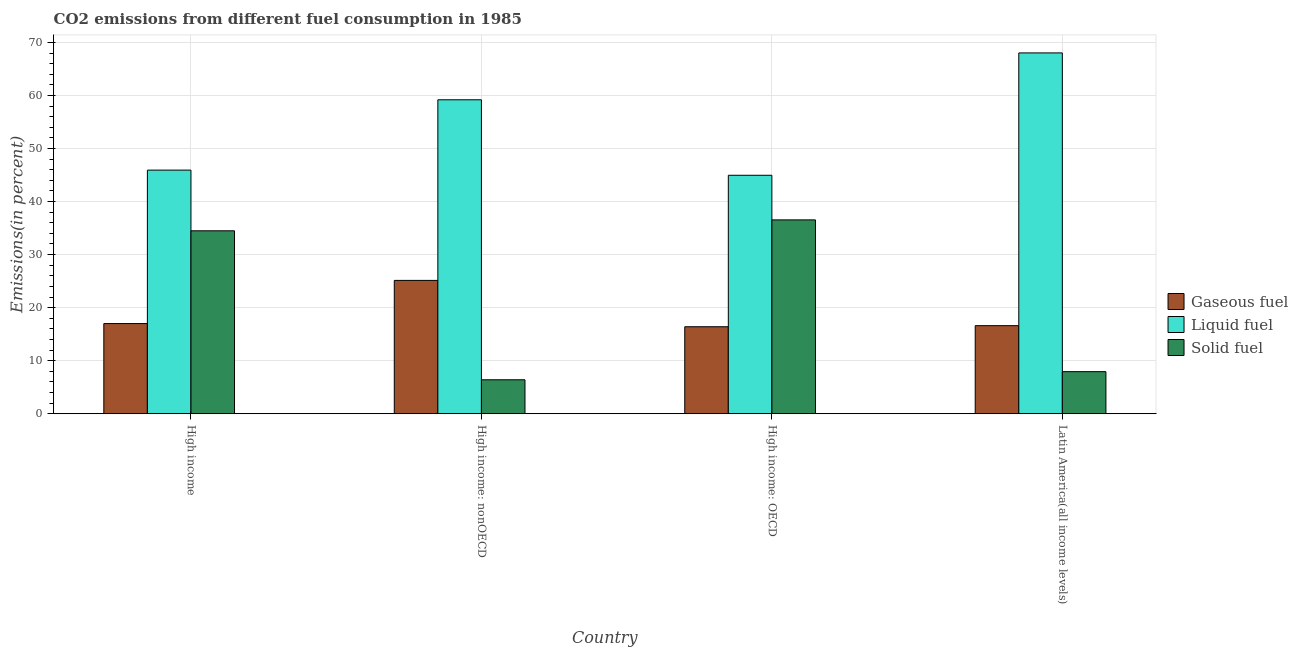How many different coloured bars are there?
Ensure brevity in your answer.  3. How many groups of bars are there?
Provide a succinct answer. 4. Are the number of bars per tick equal to the number of legend labels?
Provide a succinct answer. Yes. What is the percentage of solid fuel emission in High income?
Your response must be concise. 34.49. Across all countries, what is the maximum percentage of solid fuel emission?
Provide a short and direct response. 36.54. Across all countries, what is the minimum percentage of liquid fuel emission?
Provide a succinct answer. 44.96. In which country was the percentage of liquid fuel emission maximum?
Provide a succinct answer. Latin America(all income levels). In which country was the percentage of liquid fuel emission minimum?
Your response must be concise. High income: OECD. What is the total percentage of solid fuel emission in the graph?
Your answer should be compact. 85.36. What is the difference between the percentage of solid fuel emission in High income: OECD and that in Latin America(all income levels)?
Make the answer very short. 28.61. What is the difference between the percentage of gaseous fuel emission in High income: OECD and the percentage of solid fuel emission in High income?
Give a very brief answer. -18.08. What is the average percentage of gaseous fuel emission per country?
Give a very brief answer. 18.78. What is the difference between the percentage of gaseous fuel emission and percentage of liquid fuel emission in High income?
Your response must be concise. -28.93. In how many countries, is the percentage of liquid fuel emission greater than 38 %?
Offer a terse response. 4. What is the ratio of the percentage of solid fuel emission in High income: nonOECD to that in Latin America(all income levels)?
Offer a terse response. 0.81. Is the percentage of gaseous fuel emission in High income: OECD less than that in High income: nonOECD?
Your answer should be compact. Yes. What is the difference between the highest and the second highest percentage of gaseous fuel emission?
Ensure brevity in your answer.  8.14. What is the difference between the highest and the lowest percentage of liquid fuel emission?
Offer a terse response. 23.07. Is the sum of the percentage of gaseous fuel emission in High income: nonOECD and Latin America(all income levels) greater than the maximum percentage of solid fuel emission across all countries?
Your answer should be very brief. Yes. What does the 3rd bar from the left in High income represents?
Make the answer very short. Solid fuel. What does the 3rd bar from the right in High income: OECD represents?
Provide a succinct answer. Gaseous fuel. Where does the legend appear in the graph?
Your response must be concise. Center right. How many legend labels are there?
Ensure brevity in your answer.  3. What is the title of the graph?
Ensure brevity in your answer.  CO2 emissions from different fuel consumption in 1985. What is the label or title of the Y-axis?
Provide a short and direct response. Emissions(in percent). What is the Emissions(in percent) in Gaseous fuel in High income?
Provide a succinct answer. 17. What is the Emissions(in percent) of Liquid fuel in High income?
Your answer should be compact. 45.93. What is the Emissions(in percent) in Solid fuel in High income?
Keep it short and to the point. 34.49. What is the Emissions(in percent) of Gaseous fuel in High income: nonOECD?
Give a very brief answer. 25.14. What is the Emissions(in percent) of Liquid fuel in High income: nonOECD?
Give a very brief answer. 59.19. What is the Emissions(in percent) of Solid fuel in High income: nonOECD?
Provide a short and direct response. 6.4. What is the Emissions(in percent) in Gaseous fuel in High income: OECD?
Your answer should be compact. 16.4. What is the Emissions(in percent) in Liquid fuel in High income: OECD?
Give a very brief answer. 44.96. What is the Emissions(in percent) of Solid fuel in High income: OECD?
Your response must be concise. 36.54. What is the Emissions(in percent) of Gaseous fuel in Latin America(all income levels)?
Make the answer very short. 16.6. What is the Emissions(in percent) of Liquid fuel in Latin America(all income levels)?
Provide a succinct answer. 68.02. What is the Emissions(in percent) of Solid fuel in Latin America(all income levels)?
Your answer should be very brief. 7.93. Across all countries, what is the maximum Emissions(in percent) in Gaseous fuel?
Your answer should be compact. 25.14. Across all countries, what is the maximum Emissions(in percent) of Liquid fuel?
Your response must be concise. 68.02. Across all countries, what is the maximum Emissions(in percent) in Solid fuel?
Your response must be concise. 36.54. Across all countries, what is the minimum Emissions(in percent) in Gaseous fuel?
Your answer should be very brief. 16.4. Across all countries, what is the minimum Emissions(in percent) of Liquid fuel?
Offer a very short reply. 44.96. Across all countries, what is the minimum Emissions(in percent) of Solid fuel?
Give a very brief answer. 6.4. What is the total Emissions(in percent) of Gaseous fuel in the graph?
Keep it short and to the point. 75.14. What is the total Emissions(in percent) of Liquid fuel in the graph?
Provide a short and direct response. 218.09. What is the total Emissions(in percent) in Solid fuel in the graph?
Make the answer very short. 85.36. What is the difference between the Emissions(in percent) in Gaseous fuel in High income and that in High income: nonOECD?
Your answer should be very brief. -8.14. What is the difference between the Emissions(in percent) of Liquid fuel in High income and that in High income: nonOECD?
Make the answer very short. -13.26. What is the difference between the Emissions(in percent) of Solid fuel in High income and that in High income: nonOECD?
Provide a succinct answer. 28.08. What is the difference between the Emissions(in percent) of Gaseous fuel in High income and that in High income: OECD?
Make the answer very short. 0.6. What is the difference between the Emissions(in percent) of Liquid fuel in High income and that in High income: OECD?
Offer a terse response. 0.97. What is the difference between the Emissions(in percent) of Solid fuel in High income and that in High income: OECD?
Offer a very short reply. -2.06. What is the difference between the Emissions(in percent) in Gaseous fuel in High income and that in Latin America(all income levels)?
Your response must be concise. 0.4. What is the difference between the Emissions(in percent) of Liquid fuel in High income and that in Latin America(all income levels)?
Your response must be concise. -22.09. What is the difference between the Emissions(in percent) in Solid fuel in High income and that in Latin America(all income levels)?
Your answer should be compact. 26.55. What is the difference between the Emissions(in percent) in Gaseous fuel in High income: nonOECD and that in High income: OECD?
Ensure brevity in your answer.  8.74. What is the difference between the Emissions(in percent) of Liquid fuel in High income: nonOECD and that in High income: OECD?
Ensure brevity in your answer.  14.23. What is the difference between the Emissions(in percent) of Solid fuel in High income: nonOECD and that in High income: OECD?
Your response must be concise. -30.14. What is the difference between the Emissions(in percent) of Gaseous fuel in High income: nonOECD and that in Latin America(all income levels)?
Provide a succinct answer. 8.54. What is the difference between the Emissions(in percent) in Liquid fuel in High income: nonOECD and that in Latin America(all income levels)?
Keep it short and to the point. -8.84. What is the difference between the Emissions(in percent) in Solid fuel in High income: nonOECD and that in Latin America(all income levels)?
Ensure brevity in your answer.  -1.53. What is the difference between the Emissions(in percent) in Gaseous fuel in High income: OECD and that in Latin America(all income levels)?
Keep it short and to the point. -0.2. What is the difference between the Emissions(in percent) in Liquid fuel in High income: OECD and that in Latin America(all income levels)?
Keep it short and to the point. -23.07. What is the difference between the Emissions(in percent) in Solid fuel in High income: OECD and that in Latin America(all income levels)?
Your answer should be very brief. 28.61. What is the difference between the Emissions(in percent) of Gaseous fuel in High income and the Emissions(in percent) of Liquid fuel in High income: nonOECD?
Provide a succinct answer. -42.19. What is the difference between the Emissions(in percent) in Gaseous fuel in High income and the Emissions(in percent) in Solid fuel in High income: nonOECD?
Your response must be concise. 10.59. What is the difference between the Emissions(in percent) in Liquid fuel in High income and the Emissions(in percent) in Solid fuel in High income: nonOECD?
Offer a very short reply. 39.52. What is the difference between the Emissions(in percent) in Gaseous fuel in High income and the Emissions(in percent) in Liquid fuel in High income: OECD?
Provide a succinct answer. -27.96. What is the difference between the Emissions(in percent) of Gaseous fuel in High income and the Emissions(in percent) of Solid fuel in High income: OECD?
Your answer should be compact. -19.55. What is the difference between the Emissions(in percent) of Liquid fuel in High income and the Emissions(in percent) of Solid fuel in High income: OECD?
Offer a terse response. 9.38. What is the difference between the Emissions(in percent) in Gaseous fuel in High income and the Emissions(in percent) in Liquid fuel in Latin America(all income levels)?
Give a very brief answer. -51.02. What is the difference between the Emissions(in percent) in Gaseous fuel in High income and the Emissions(in percent) in Solid fuel in Latin America(all income levels)?
Offer a very short reply. 9.07. What is the difference between the Emissions(in percent) in Liquid fuel in High income and the Emissions(in percent) in Solid fuel in Latin America(all income levels)?
Offer a very short reply. 38. What is the difference between the Emissions(in percent) of Gaseous fuel in High income: nonOECD and the Emissions(in percent) of Liquid fuel in High income: OECD?
Make the answer very short. -19.82. What is the difference between the Emissions(in percent) in Gaseous fuel in High income: nonOECD and the Emissions(in percent) in Solid fuel in High income: OECD?
Offer a very short reply. -11.41. What is the difference between the Emissions(in percent) of Liquid fuel in High income: nonOECD and the Emissions(in percent) of Solid fuel in High income: OECD?
Your answer should be compact. 22.64. What is the difference between the Emissions(in percent) in Gaseous fuel in High income: nonOECD and the Emissions(in percent) in Liquid fuel in Latin America(all income levels)?
Your answer should be very brief. -42.88. What is the difference between the Emissions(in percent) in Gaseous fuel in High income: nonOECD and the Emissions(in percent) in Solid fuel in Latin America(all income levels)?
Your answer should be very brief. 17.21. What is the difference between the Emissions(in percent) of Liquid fuel in High income: nonOECD and the Emissions(in percent) of Solid fuel in Latin America(all income levels)?
Provide a short and direct response. 51.25. What is the difference between the Emissions(in percent) of Gaseous fuel in High income: OECD and the Emissions(in percent) of Liquid fuel in Latin America(all income levels)?
Give a very brief answer. -51.62. What is the difference between the Emissions(in percent) of Gaseous fuel in High income: OECD and the Emissions(in percent) of Solid fuel in Latin America(all income levels)?
Provide a short and direct response. 8.47. What is the difference between the Emissions(in percent) of Liquid fuel in High income: OECD and the Emissions(in percent) of Solid fuel in Latin America(all income levels)?
Keep it short and to the point. 37.02. What is the average Emissions(in percent) of Gaseous fuel per country?
Provide a succinct answer. 18.78. What is the average Emissions(in percent) in Liquid fuel per country?
Provide a short and direct response. 54.52. What is the average Emissions(in percent) of Solid fuel per country?
Provide a succinct answer. 21.34. What is the difference between the Emissions(in percent) in Gaseous fuel and Emissions(in percent) in Liquid fuel in High income?
Make the answer very short. -28.93. What is the difference between the Emissions(in percent) in Gaseous fuel and Emissions(in percent) in Solid fuel in High income?
Your answer should be very brief. -17.49. What is the difference between the Emissions(in percent) in Liquid fuel and Emissions(in percent) in Solid fuel in High income?
Ensure brevity in your answer.  11.44. What is the difference between the Emissions(in percent) in Gaseous fuel and Emissions(in percent) in Liquid fuel in High income: nonOECD?
Your answer should be very brief. -34.05. What is the difference between the Emissions(in percent) of Gaseous fuel and Emissions(in percent) of Solid fuel in High income: nonOECD?
Your response must be concise. 18.73. What is the difference between the Emissions(in percent) of Liquid fuel and Emissions(in percent) of Solid fuel in High income: nonOECD?
Give a very brief answer. 52.78. What is the difference between the Emissions(in percent) of Gaseous fuel and Emissions(in percent) of Liquid fuel in High income: OECD?
Keep it short and to the point. -28.55. What is the difference between the Emissions(in percent) of Gaseous fuel and Emissions(in percent) of Solid fuel in High income: OECD?
Give a very brief answer. -20.14. What is the difference between the Emissions(in percent) of Liquid fuel and Emissions(in percent) of Solid fuel in High income: OECD?
Provide a succinct answer. 8.41. What is the difference between the Emissions(in percent) of Gaseous fuel and Emissions(in percent) of Liquid fuel in Latin America(all income levels)?
Your response must be concise. -51.42. What is the difference between the Emissions(in percent) in Gaseous fuel and Emissions(in percent) in Solid fuel in Latin America(all income levels)?
Make the answer very short. 8.67. What is the difference between the Emissions(in percent) of Liquid fuel and Emissions(in percent) of Solid fuel in Latin America(all income levels)?
Your answer should be compact. 60.09. What is the ratio of the Emissions(in percent) of Gaseous fuel in High income to that in High income: nonOECD?
Give a very brief answer. 0.68. What is the ratio of the Emissions(in percent) in Liquid fuel in High income to that in High income: nonOECD?
Your answer should be compact. 0.78. What is the ratio of the Emissions(in percent) of Solid fuel in High income to that in High income: nonOECD?
Your answer should be compact. 5.38. What is the ratio of the Emissions(in percent) of Gaseous fuel in High income to that in High income: OECD?
Offer a very short reply. 1.04. What is the ratio of the Emissions(in percent) of Liquid fuel in High income to that in High income: OECD?
Provide a short and direct response. 1.02. What is the ratio of the Emissions(in percent) of Solid fuel in High income to that in High income: OECD?
Your answer should be compact. 0.94. What is the ratio of the Emissions(in percent) of Gaseous fuel in High income to that in Latin America(all income levels)?
Your answer should be compact. 1.02. What is the ratio of the Emissions(in percent) of Liquid fuel in High income to that in Latin America(all income levels)?
Your answer should be compact. 0.68. What is the ratio of the Emissions(in percent) in Solid fuel in High income to that in Latin America(all income levels)?
Offer a very short reply. 4.35. What is the ratio of the Emissions(in percent) of Gaseous fuel in High income: nonOECD to that in High income: OECD?
Ensure brevity in your answer.  1.53. What is the ratio of the Emissions(in percent) of Liquid fuel in High income: nonOECD to that in High income: OECD?
Offer a terse response. 1.32. What is the ratio of the Emissions(in percent) of Solid fuel in High income: nonOECD to that in High income: OECD?
Offer a very short reply. 0.18. What is the ratio of the Emissions(in percent) of Gaseous fuel in High income: nonOECD to that in Latin America(all income levels)?
Keep it short and to the point. 1.51. What is the ratio of the Emissions(in percent) of Liquid fuel in High income: nonOECD to that in Latin America(all income levels)?
Your response must be concise. 0.87. What is the ratio of the Emissions(in percent) in Solid fuel in High income: nonOECD to that in Latin America(all income levels)?
Offer a very short reply. 0.81. What is the ratio of the Emissions(in percent) in Gaseous fuel in High income: OECD to that in Latin America(all income levels)?
Provide a short and direct response. 0.99. What is the ratio of the Emissions(in percent) in Liquid fuel in High income: OECD to that in Latin America(all income levels)?
Ensure brevity in your answer.  0.66. What is the ratio of the Emissions(in percent) in Solid fuel in High income: OECD to that in Latin America(all income levels)?
Your answer should be compact. 4.61. What is the difference between the highest and the second highest Emissions(in percent) in Gaseous fuel?
Provide a short and direct response. 8.14. What is the difference between the highest and the second highest Emissions(in percent) of Liquid fuel?
Offer a very short reply. 8.84. What is the difference between the highest and the second highest Emissions(in percent) of Solid fuel?
Your answer should be compact. 2.06. What is the difference between the highest and the lowest Emissions(in percent) of Gaseous fuel?
Offer a terse response. 8.74. What is the difference between the highest and the lowest Emissions(in percent) of Liquid fuel?
Make the answer very short. 23.07. What is the difference between the highest and the lowest Emissions(in percent) in Solid fuel?
Give a very brief answer. 30.14. 